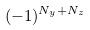Convert formula to latex. <formula><loc_0><loc_0><loc_500><loc_500>( - 1 ) ^ { N _ { y } + N _ { z } }</formula> 